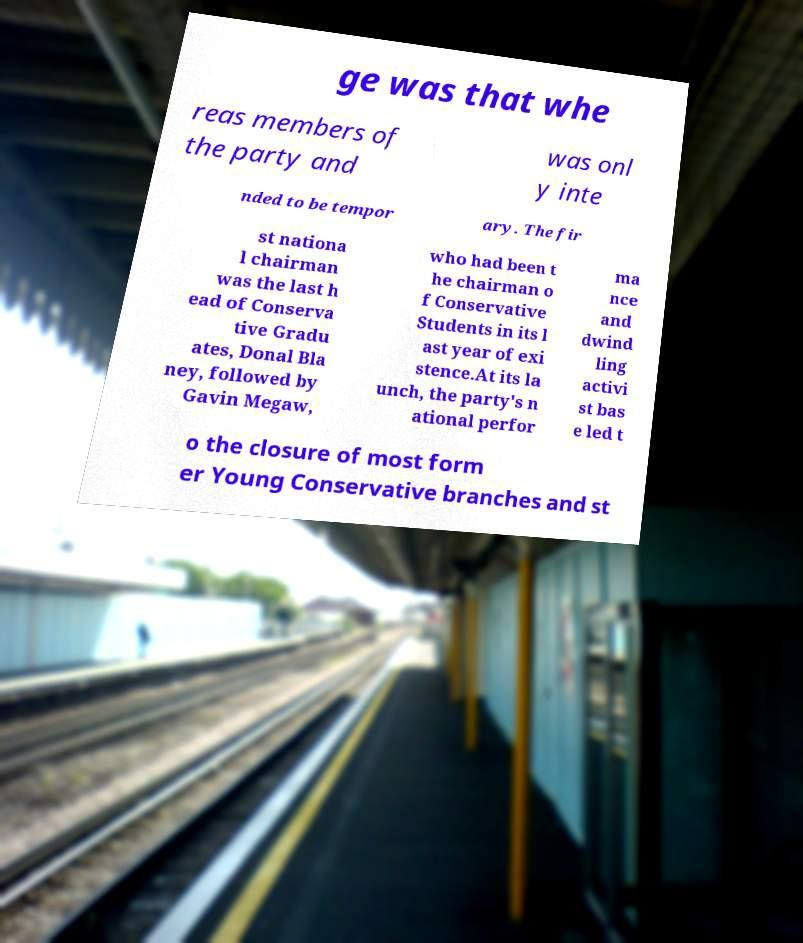Please read and relay the text visible in this image. What does it say? ge was that whe reas members of the party and was onl y inte nded to be tempor ary. The fir st nationa l chairman was the last h ead of Conserva tive Gradu ates, Donal Bla ney, followed by Gavin Megaw, who had been t he chairman o f Conservative Students in its l ast year of exi stence.At its la unch, the party's n ational perfor ma nce and dwind ling activi st bas e led t o the closure of most form er Young Conservative branches and st 